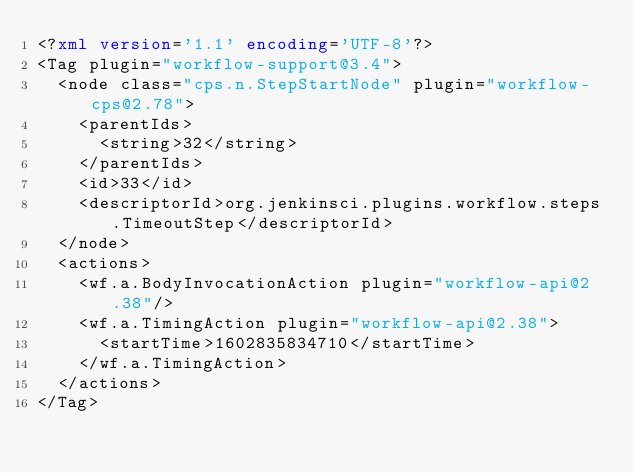<code> <loc_0><loc_0><loc_500><loc_500><_XML_><?xml version='1.1' encoding='UTF-8'?>
<Tag plugin="workflow-support@3.4">
  <node class="cps.n.StepStartNode" plugin="workflow-cps@2.78">
    <parentIds>
      <string>32</string>
    </parentIds>
    <id>33</id>
    <descriptorId>org.jenkinsci.plugins.workflow.steps.TimeoutStep</descriptorId>
  </node>
  <actions>
    <wf.a.BodyInvocationAction plugin="workflow-api@2.38"/>
    <wf.a.TimingAction plugin="workflow-api@2.38">
      <startTime>1602835834710</startTime>
    </wf.a.TimingAction>
  </actions>
</Tag></code> 